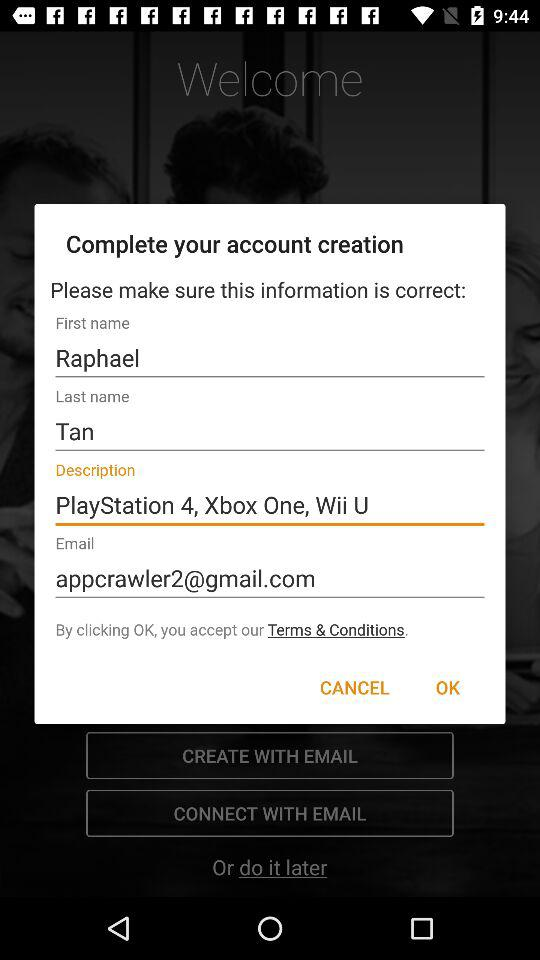What is the given description? The given description is "PlayStation 4, Xbox One, Wii U". 